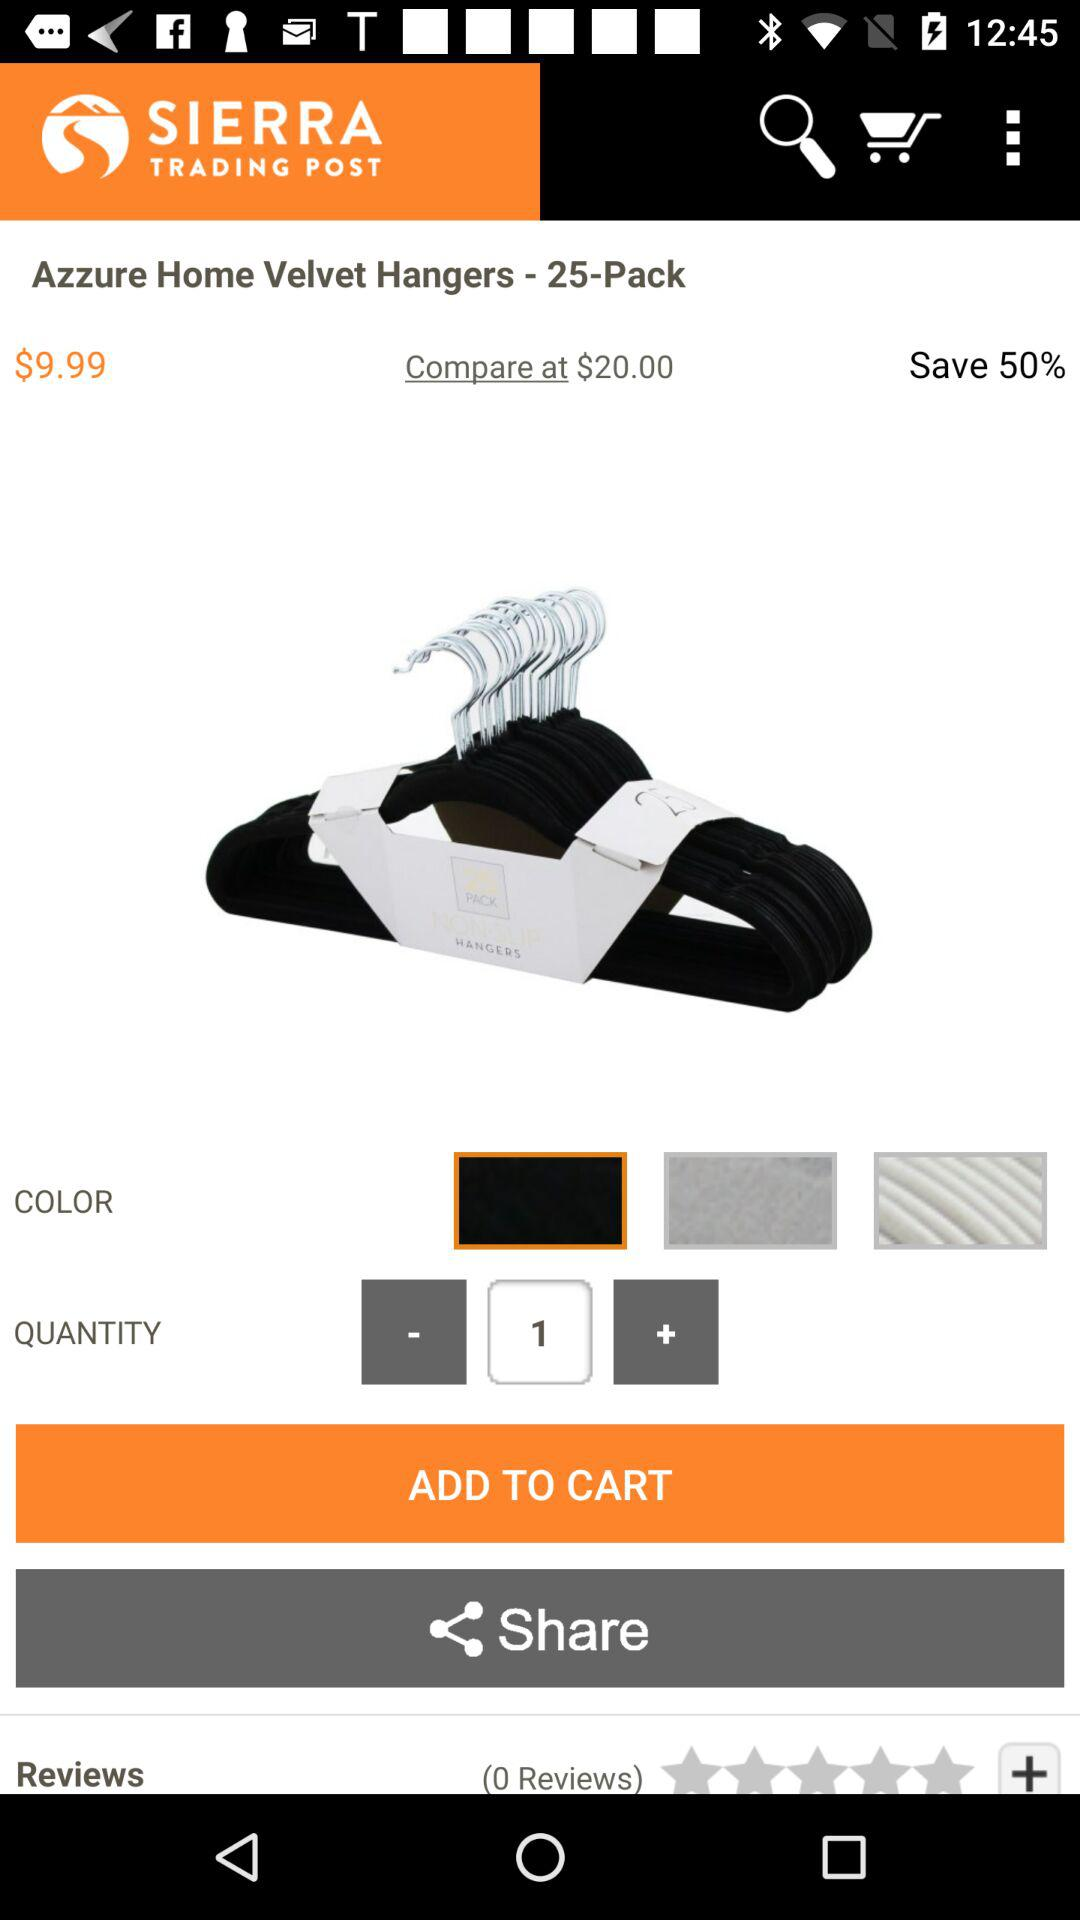What is the percentage of savings? The percentage of savings is 50. 